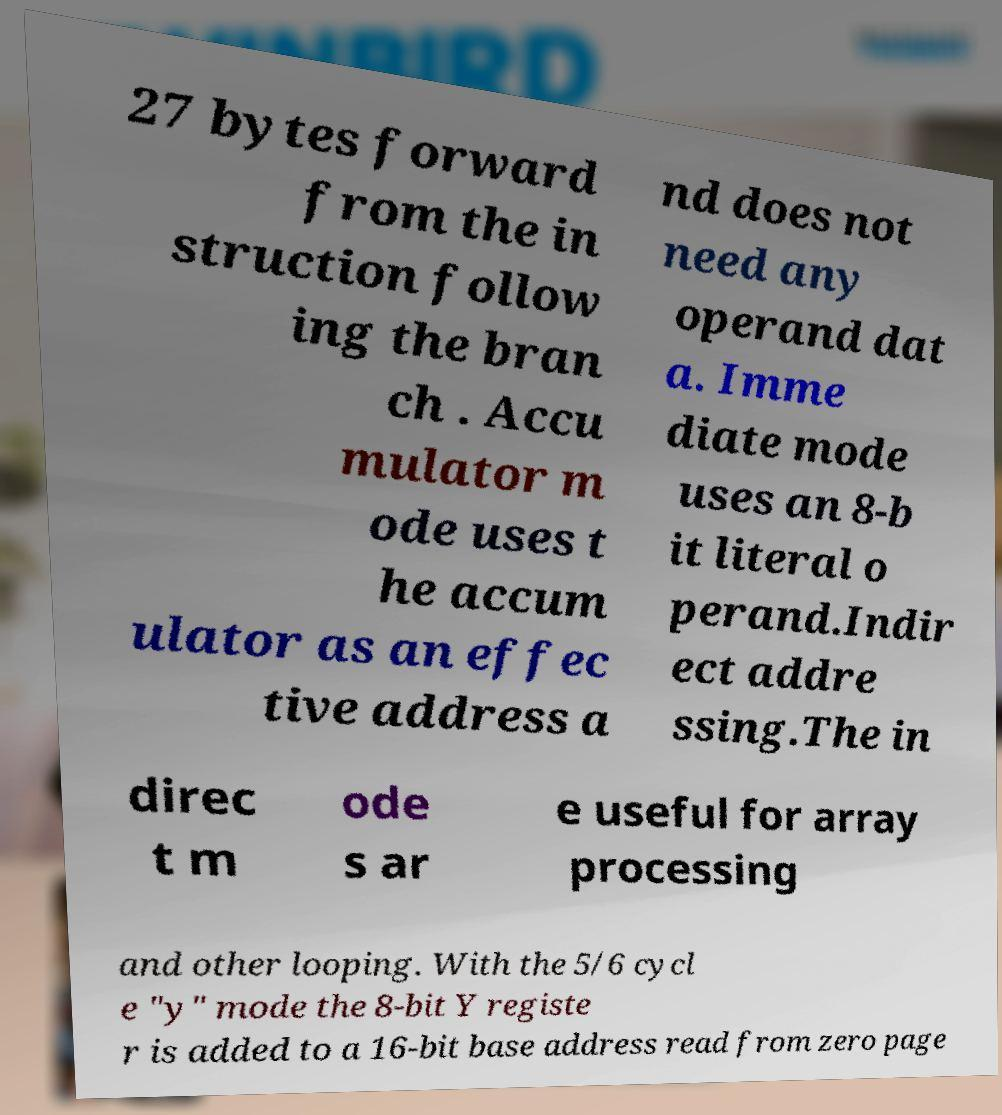Can you accurately transcribe the text from the provided image for me? 27 bytes forward from the in struction follow ing the bran ch . Accu mulator m ode uses t he accum ulator as an effec tive address a nd does not need any operand dat a. Imme diate mode uses an 8-b it literal o perand.Indir ect addre ssing.The in direc t m ode s ar e useful for array processing and other looping. With the 5/6 cycl e "y" mode the 8-bit Y registe r is added to a 16-bit base address read from zero page 